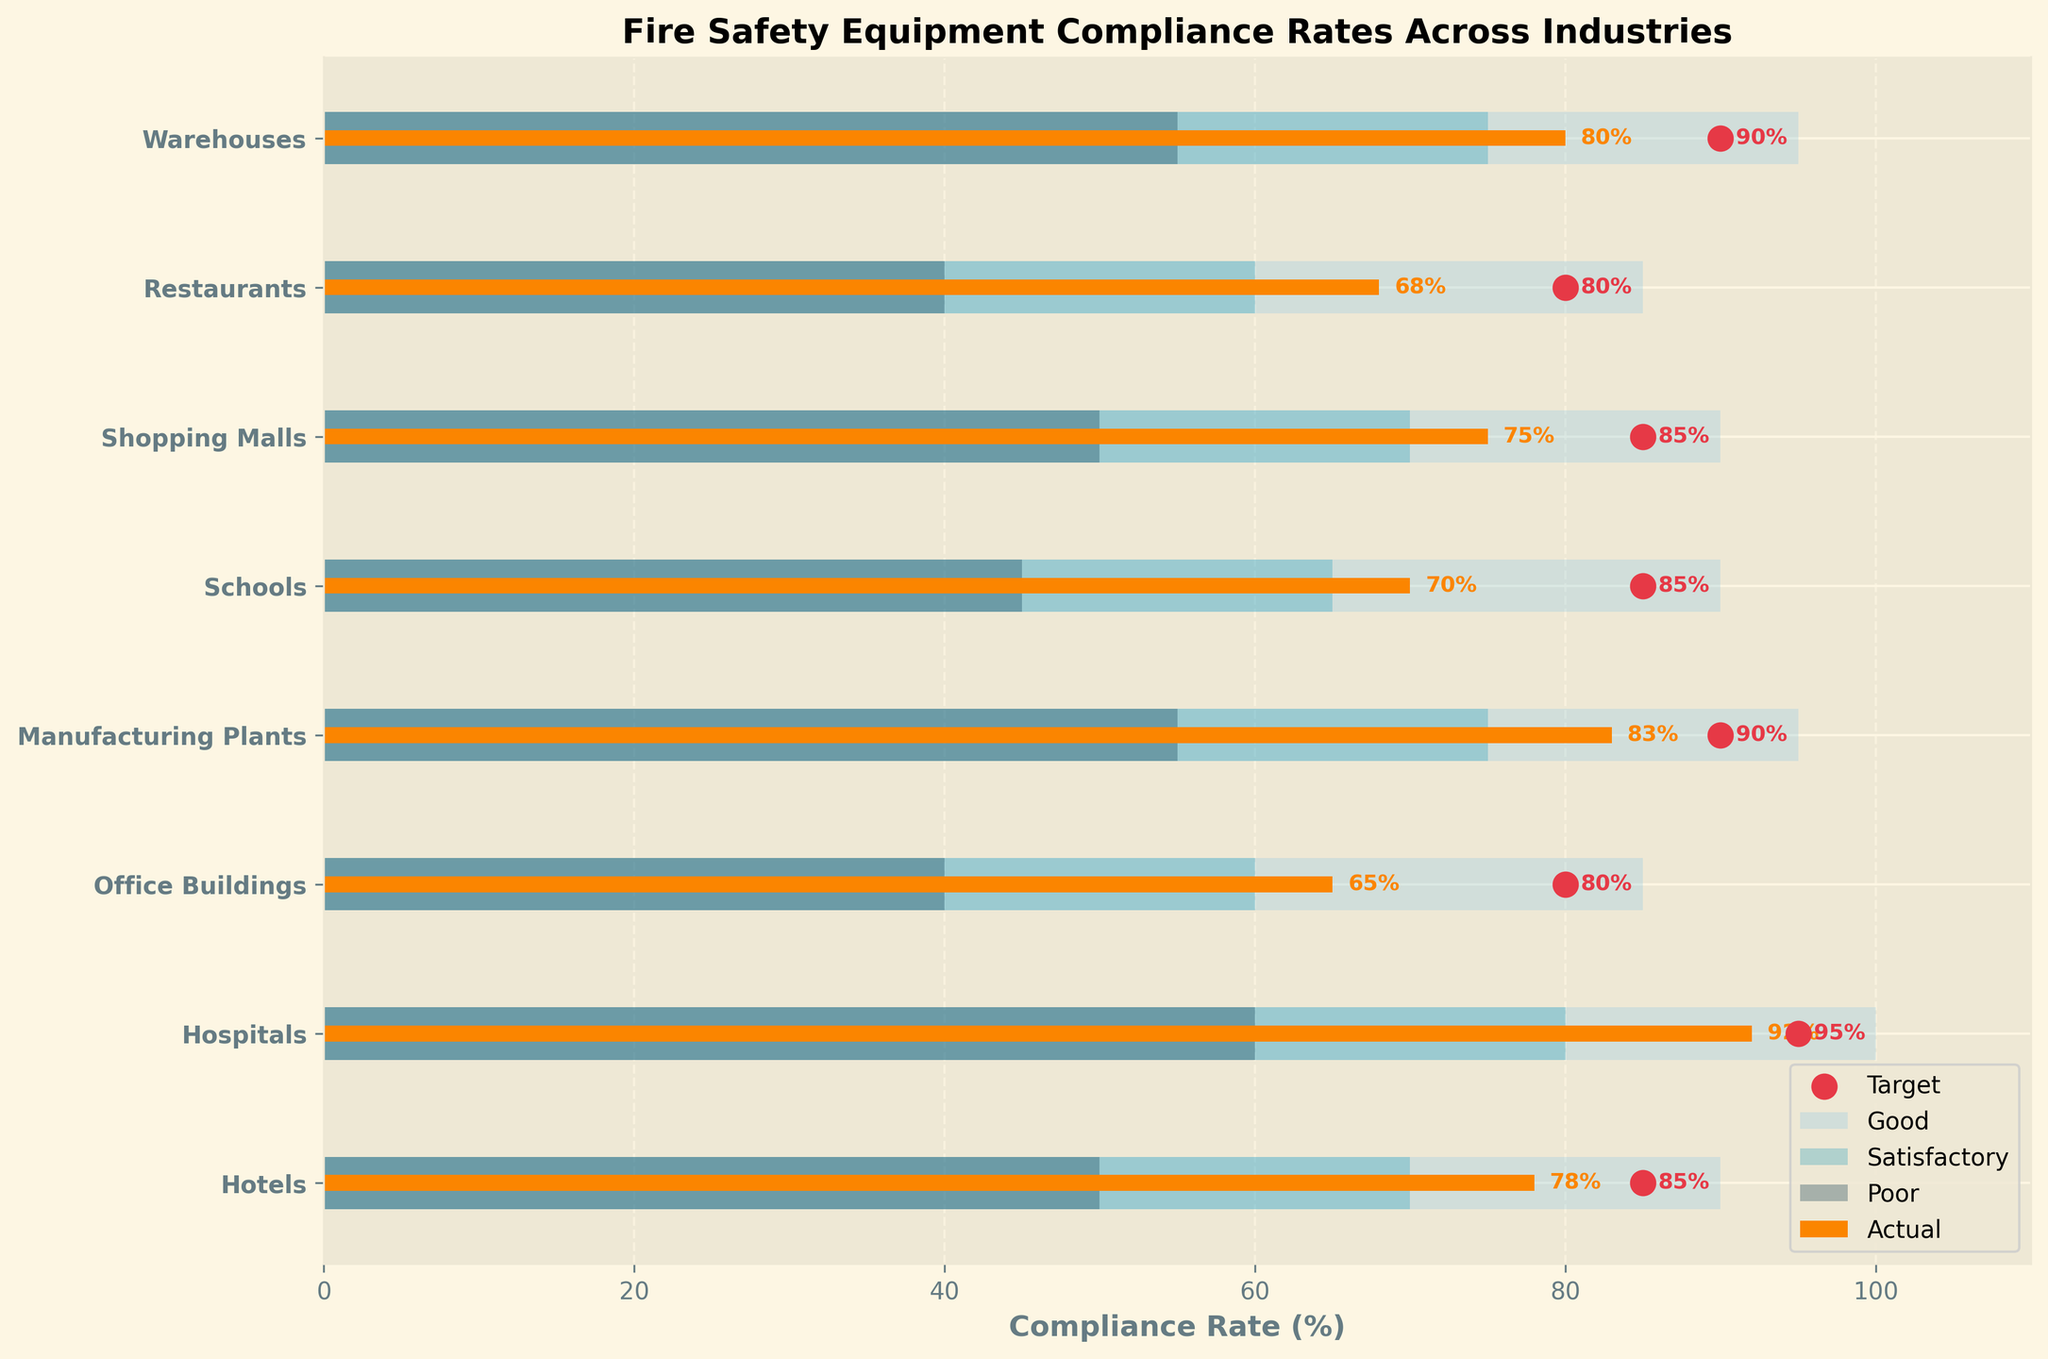What industry has the highest compliance rate? The highest compliance rate can be observed in the "Hospitals" category with an actual value of 92%.
Answer: Hospitals What's the difference between the actual and target compliance rates for Manufacturing Plants? The actual compliance rate for Manufacturing Plants is 83%, and the target is 90%. The difference is 90 - 83 = 7%.
Answer: 7% What is the average compliance rate across all industries? Add up the actual compliance rates for all industries (78 + 92 + 65 + 83 + 70 + 75 + 68 + 80) = 611. Divide by the number of categories (8), so 611 / 8 = 76.375%.
Answer: 76.375% Which industry is closest to its target compliance rate? Comparing the difference between the actual and target compliance rates for each industry, Hospitals (92 vs. 95), with a difference of 3%. This is the smallest difference.
Answer: Hospitals How many industries have an actual compliance rate above 80%? Counting the industries with compliance rates above 80%: "Hospitals" (92), "Manufacturing Plants" (83), and "Warehouses" (80), we get 3 industries.
Answer: 3 Which industry has the lowest compliance rate, and what is it? The lowest compliance rate is in "Office Buildings" with an actual value of 65%.
Answer: Office Buildings, 65% Are there any industries where the actual compliance rate falls into the "Poor" category range? The "Poor" category range varies by industry. No industries have actual compliance rates falling into the poor category as all actual rates are above 60%.
Answer: No What's the median compliance rate across all industries? First, sort the actual rates: 65, 68, 70, 75, 78, 80, 83, 92. The middle values are 75 and 78. The median is (75 + 78) / 2 = 76.5%.
Answer: 76.5% By how much does the compliance rate in Restaurants fall short of the target? The actual compliance rate for Restaurants is 68%, and the target is 80%. The shortfall is 80 - 68 = 12%.
Answer: 12% How many industries have both their actual compliance rate below 80% and their target compliance rate above 80%? The industries with actual rates below 80% and target rates above 80% are: "Office Buildings", "Schools", "Shopping Malls", "Restaurants", number is 4.
Answer: 4 